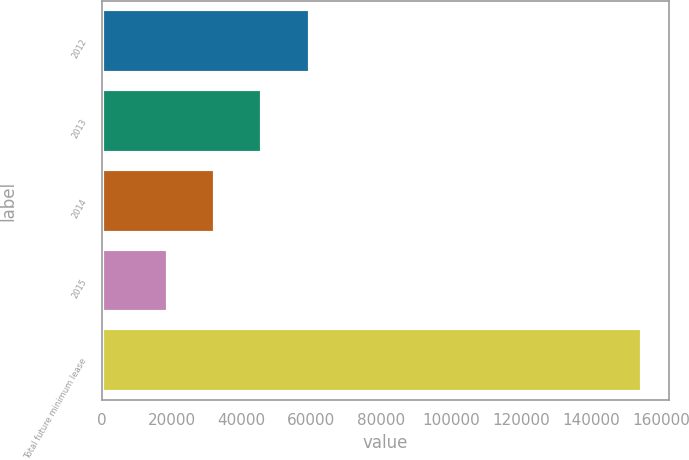Convert chart. <chart><loc_0><loc_0><loc_500><loc_500><bar_chart><fcel>2012<fcel>2013<fcel>2014<fcel>2015<fcel>Total future minimum lease<nl><fcel>59536.9<fcel>45963.6<fcel>32390.3<fcel>18817<fcel>154550<nl></chart> 